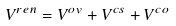<formula> <loc_0><loc_0><loc_500><loc_500>V ^ { r e n } = V ^ { o v } + V ^ { c s } + V ^ { c o }</formula> 